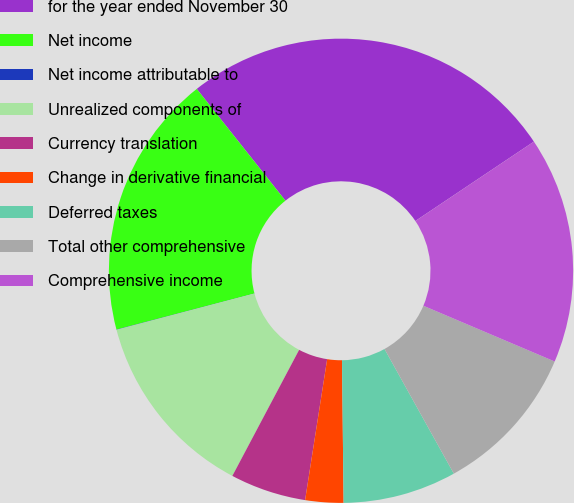<chart> <loc_0><loc_0><loc_500><loc_500><pie_chart><fcel>for the year ended November 30<fcel>Net income<fcel>Net income attributable to<fcel>Unrealized components of<fcel>Currency translation<fcel>Change in derivative financial<fcel>Deferred taxes<fcel>Total other comprehensive<fcel>Comprehensive income<nl><fcel>26.28%<fcel>18.4%<fcel>0.02%<fcel>13.15%<fcel>5.28%<fcel>2.65%<fcel>7.9%<fcel>10.53%<fcel>15.78%<nl></chart> 